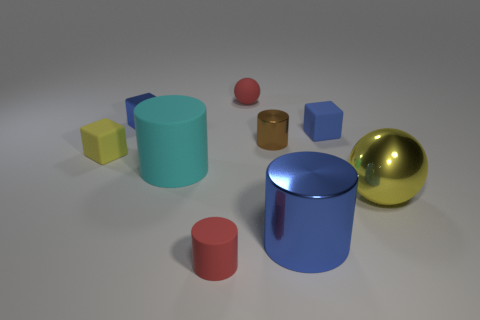Subtract all small red cylinders. How many cylinders are left? 3 Subtract all yellow blocks. How many blocks are left? 2 Subtract 2 cubes. How many cubes are left? 1 Subtract all cubes. How many objects are left? 6 Subtract all purple balls. How many brown cylinders are left? 1 Subtract all red cylinders. Subtract all brown spheres. How many cylinders are left? 3 Subtract all tiny red matte blocks. Subtract all large cyan cylinders. How many objects are left? 8 Add 2 small brown cylinders. How many small brown cylinders are left? 3 Add 4 red cylinders. How many red cylinders exist? 5 Subtract 1 cyan cylinders. How many objects are left? 8 